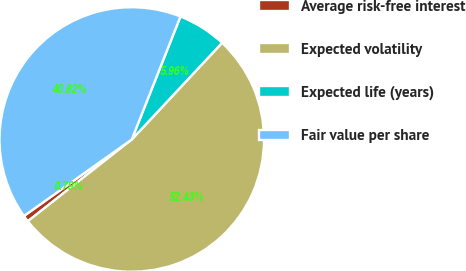Convert chart. <chart><loc_0><loc_0><loc_500><loc_500><pie_chart><fcel>Average risk-free interest<fcel>Expected volatility<fcel>Expected life (years)<fcel>Fair value per share<nl><fcel>0.79%<fcel>52.43%<fcel>5.96%<fcel>40.82%<nl></chart> 